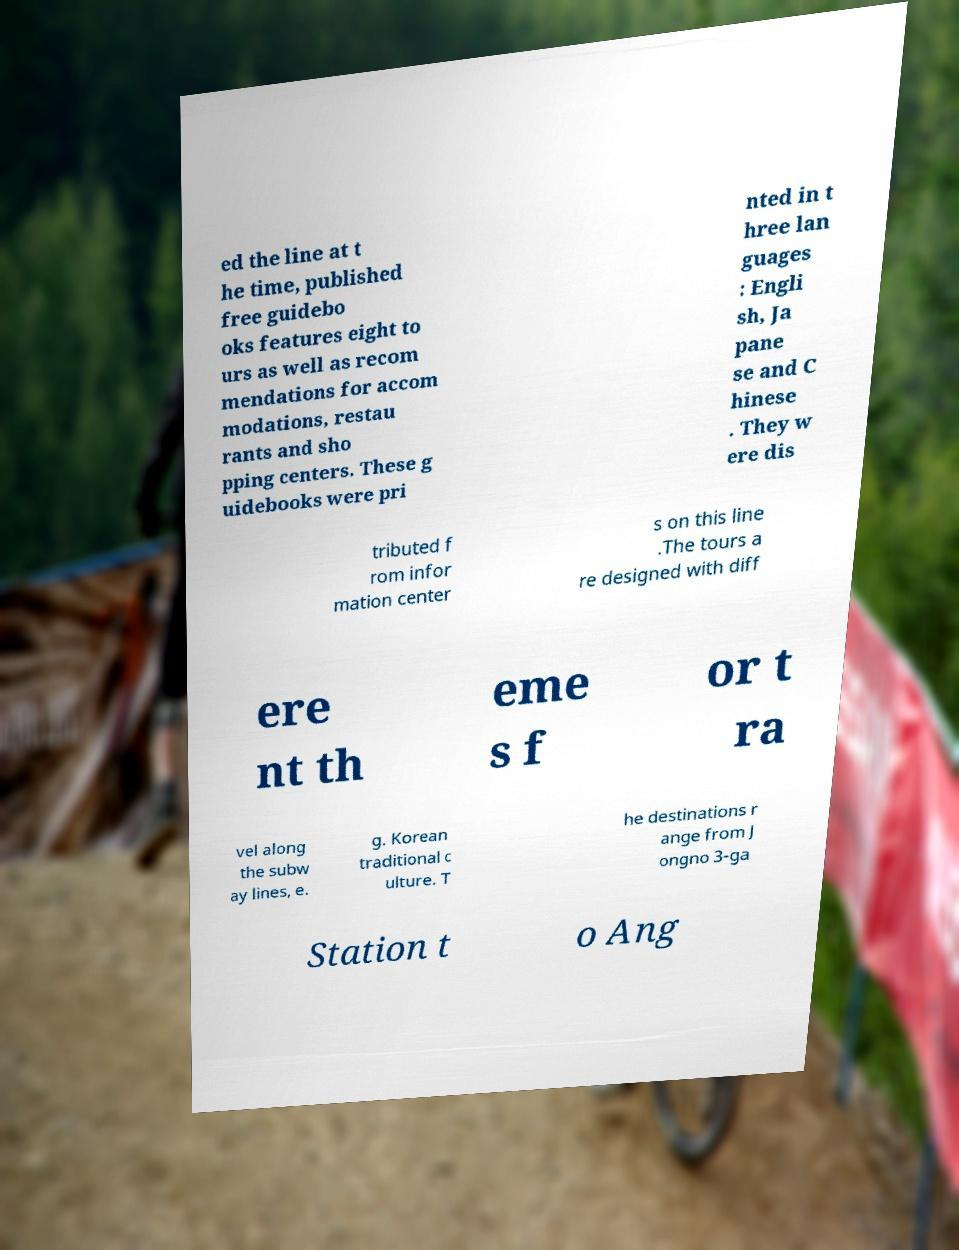There's text embedded in this image that I need extracted. Can you transcribe it verbatim? ed the line at t he time, published free guidebo oks features eight to urs as well as recom mendations for accom modations, restau rants and sho pping centers. These g uidebooks were pri nted in t hree lan guages : Engli sh, Ja pane se and C hinese . They w ere dis tributed f rom infor mation center s on this line .The tours a re designed with diff ere nt th eme s f or t ra vel along the subw ay lines, e. g. Korean traditional c ulture. T he destinations r ange from J ongno 3-ga Station t o Ang 